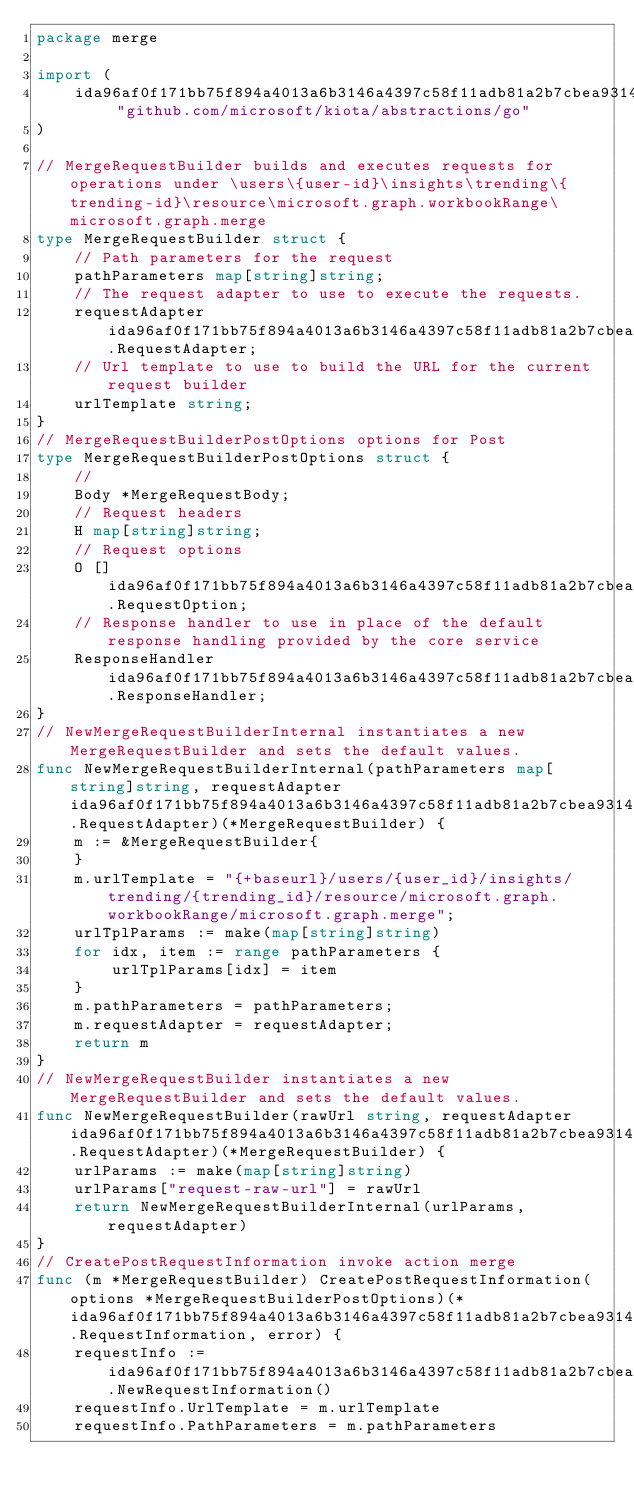<code> <loc_0><loc_0><loc_500><loc_500><_Go_>package merge

import (
    ida96af0f171bb75f894a4013a6b3146a4397c58f11adb81a2b7cbea9314783a9 "github.com/microsoft/kiota/abstractions/go"
)

// MergeRequestBuilder builds and executes requests for operations under \users\{user-id}\insights\trending\{trending-id}\resource\microsoft.graph.workbookRange\microsoft.graph.merge
type MergeRequestBuilder struct {
    // Path parameters for the request
    pathParameters map[string]string;
    // The request adapter to use to execute the requests.
    requestAdapter ida96af0f171bb75f894a4013a6b3146a4397c58f11adb81a2b7cbea9314783a9.RequestAdapter;
    // Url template to use to build the URL for the current request builder
    urlTemplate string;
}
// MergeRequestBuilderPostOptions options for Post
type MergeRequestBuilderPostOptions struct {
    // 
    Body *MergeRequestBody;
    // Request headers
    H map[string]string;
    // Request options
    O []ida96af0f171bb75f894a4013a6b3146a4397c58f11adb81a2b7cbea9314783a9.RequestOption;
    // Response handler to use in place of the default response handling provided by the core service
    ResponseHandler ida96af0f171bb75f894a4013a6b3146a4397c58f11adb81a2b7cbea9314783a9.ResponseHandler;
}
// NewMergeRequestBuilderInternal instantiates a new MergeRequestBuilder and sets the default values.
func NewMergeRequestBuilderInternal(pathParameters map[string]string, requestAdapter ida96af0f171bb75f894a4013a6b3146a4397c58f11adb81a2b7cbea9314783a9.RequestAdapter)(*MergeRequestBuilder) {
    m := &MergeRequestBuilder{
    }
    m.urlTemplate = "{+baseurl}/users/{user_id}/insights/trending/{trending_id}/resource/microsoft.graph.workbookRange/microsoft.graph.merge";
    urlTplParams := make(map[string]string)
    for idx, item := range pathParameters {
        urlTplParams[idx] = item
    }
    m.pathParameters = pathParameters;
    m.requestAdapter = requestAdapter;
    return m
}
// NewMergeRequestBuilder instantiates a new MergeRequestBuilder and sets the default values.
func NewMergeRequestBuilder(rawUrl string, requestAdapter ida96af0f171bb75f894a4013a6b3146a4397c58f11adb81a2b7cbea9314783a9.RequestAdapter)(*MergeRequestBuilder) {
    urlParams := make(map[string]string)
    urlParams["request-raw-url"] = rawUrl
    return NewMergeRequestBuilderInternal(urlParams, requestAdapter)
}
// CreatePostRequestInformation invoke action merge
func (m *MergeRequestBuilder) CreatePostRequestInformation(options *MergeRequestBuilderPostOptions)(*ida96af0f171bb75f894a4013a6b3146a4397c58f11adb81a2b7cbea9314783a9.RequestInformation, error) {
    requestInfo := ida96af0f171bb75f894a4013a6b3146a4397c58f11adb81a2b7cbea9314783a9.NewRequestInformation()
    requestInfo.UrlTemplate = m.urlTemplate
    requestInfo.PathParameters = m.pathParameters</code> 